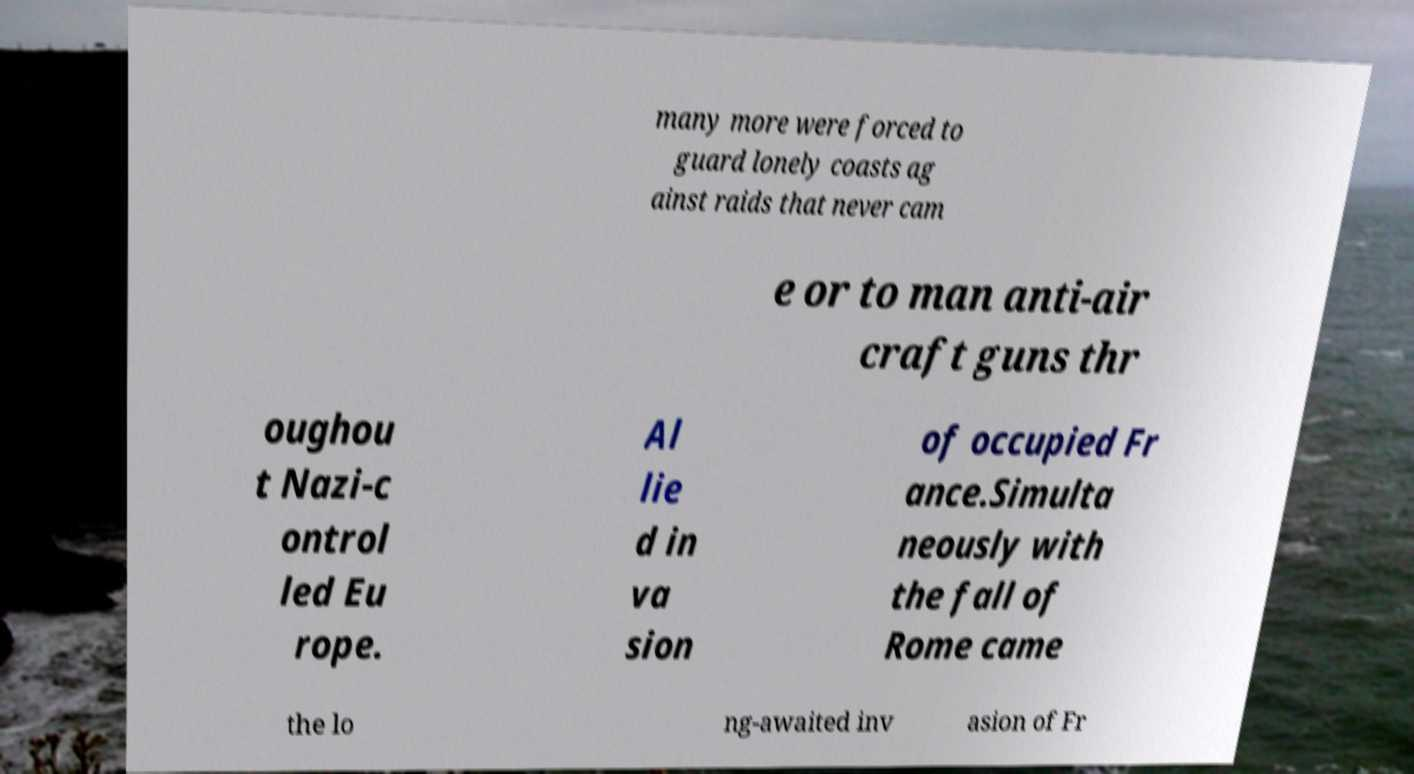Please read and relay the text visible in this image. What does it say? many more were forced to guard lonely coasts ag ainst raids that never cam e or to man anti-air craft guns thr oughou t Nazi-c ontrol led Eu rope. Al lie d in va sion of occupied Fr ance.Simulta neously with the fall of Rome came the lo ng-awaited inv asion of Fr 